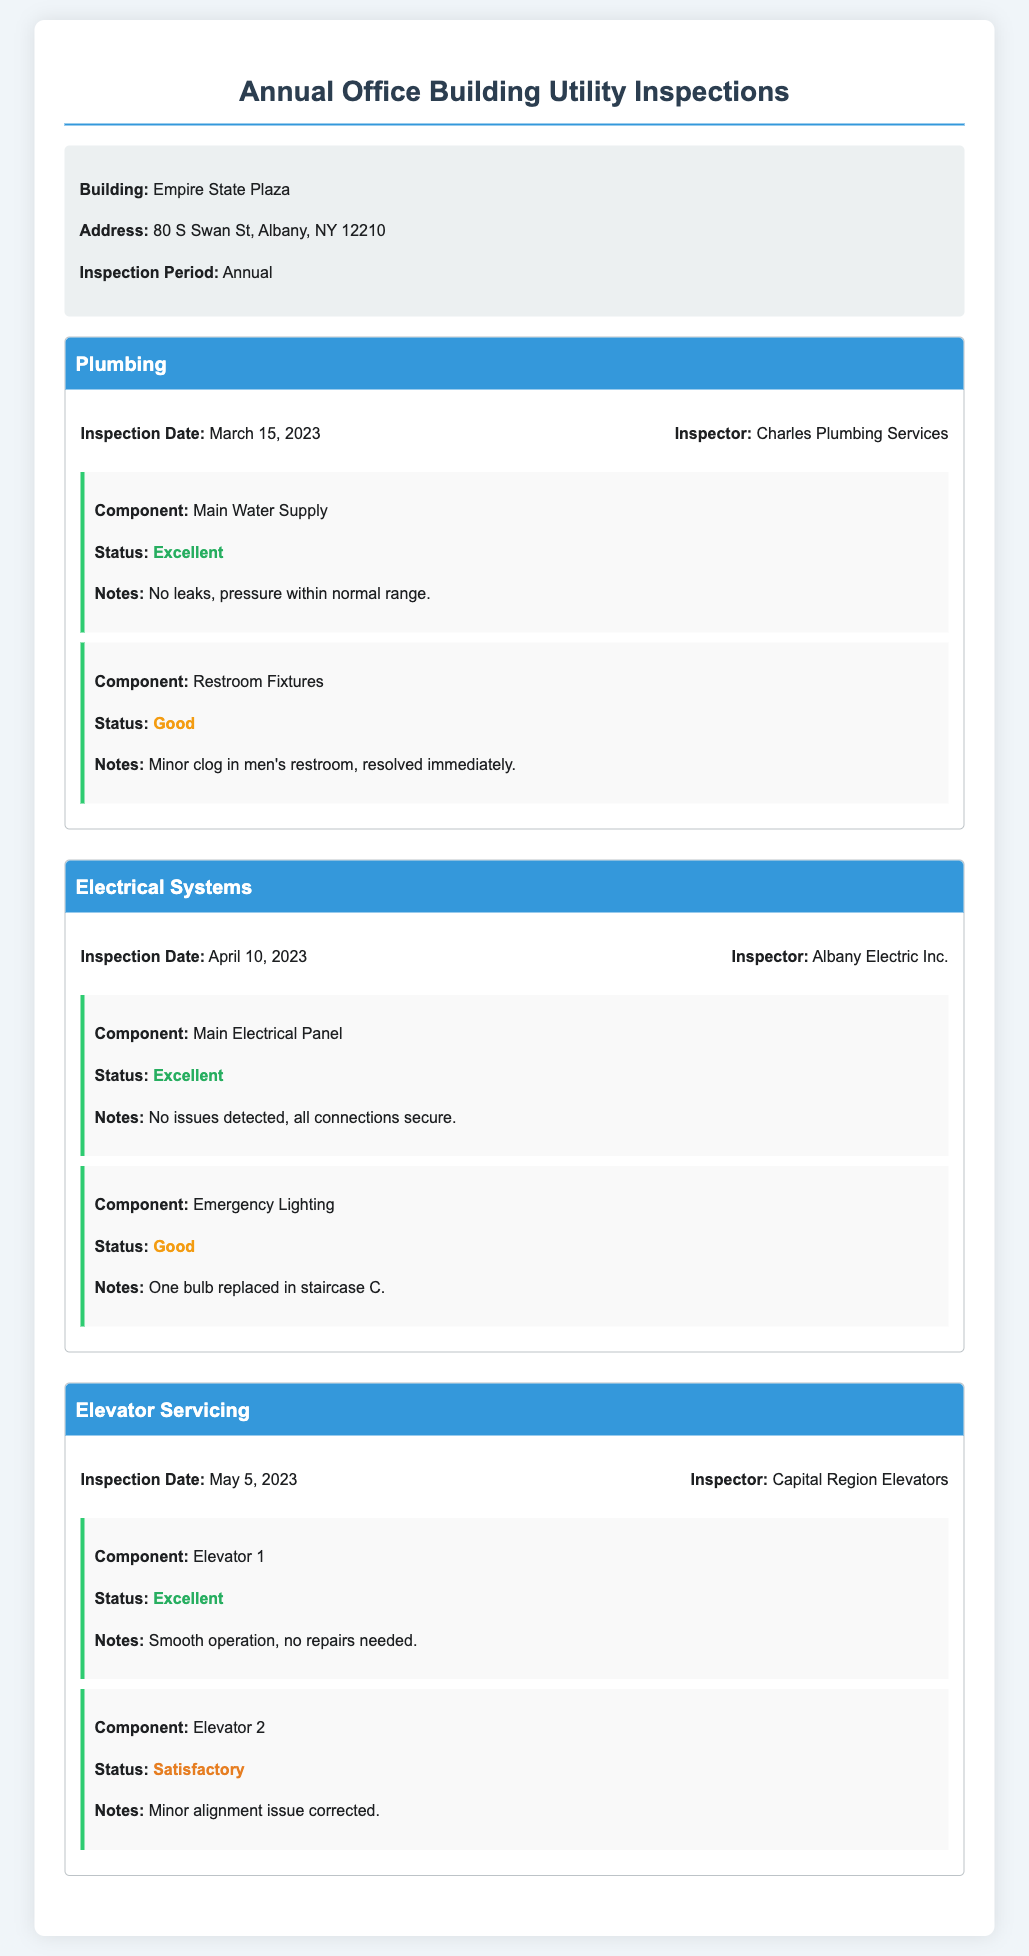What is the name of the office building? The name is provided in the building information section of the document.
Answer: Empire State Plaza What is the inspection period? The inspection period is specified in the document under building information.
Answer: Annual Who conducted the plumbing inspection? The inspector's name is listed alongside the plumbing inspection details.
Answer: Charles Plumbing Services What date was the electrical systems inspection performed? The specified date can be found in the inspection details of the electrical systems section.
Answer: April 10, 2023 What was the status of Elevator 2? The status is mentioned in the elevator servicing section under the component details.
Answer: Satisfactory What note was made about the restroom fixtures? The notes provide details about the condition of the restroom fixtures after inspection.
Answer: Minor clog in men's restroom, resolved immediately What company inspected the elevators? This information is listed in the elevator servicing inspection details.
Answer: Capital Region Elevators How many components were inspected in the plumbing section? The count of components can be derived from the number of result items in the plumbing section.
Answer: 2 What issue was noted with Emergency Lighting? The issue related to the Emergency Lighting is mentioned in the notes section.
Answer: One bulb replaced in staircase C 